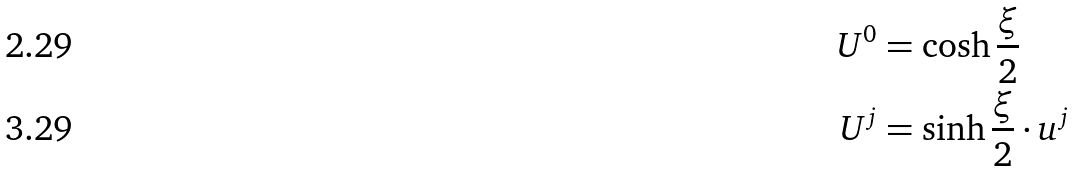<formula> <loc_0><loc_0><loc_500><loc_500>U ^ { 0 } & = \cosh \frac { \xi } { 2 } \\ U ^ { j } & = \sinh \frac { \xi } { 2 } \cdot u ^ { j }</formula> 